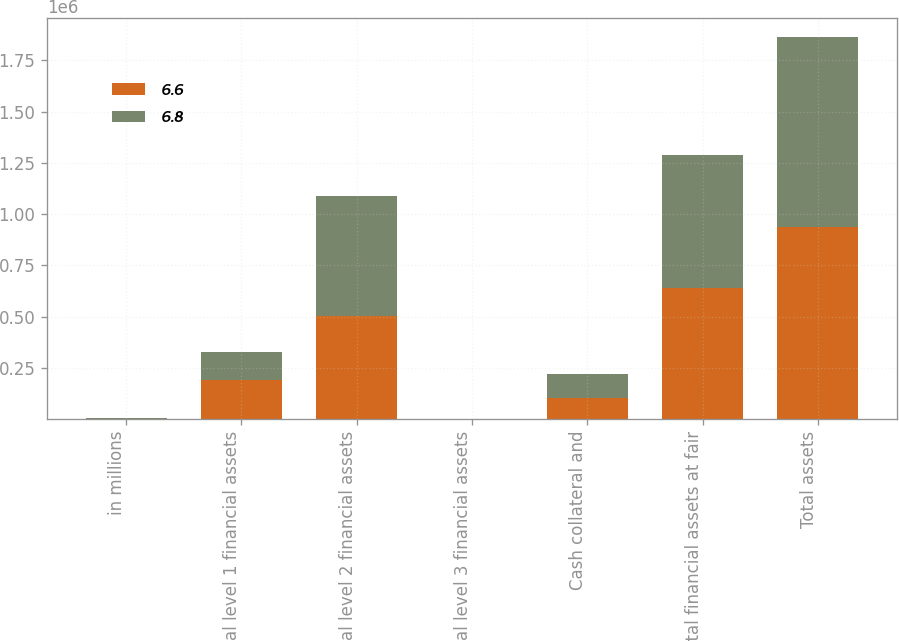<chart> <loc_0><loc_0><loc_500><loc_500><stacked_bar_chart><ecel><fcel>in millions<fcel>Total level 1 financial assets<fcel>Total level 2 financial assets<fcel>Total level 3 financial assets<fcel>Cash collateral and<fcel>Total financial assets at fair<fcel>Total assets<nl><fcel>6.6<fcel>2012<fcel>190737<fcel>502293<fcel>5<fcel>101612<fcel>638513<fcel>938555<nl><fcel>6.8<fcel>2011<fcel>136780<fcel>587416<fcel>5.2<fcel>120821<fcel>651312<fcel>923225<nl></chart> 